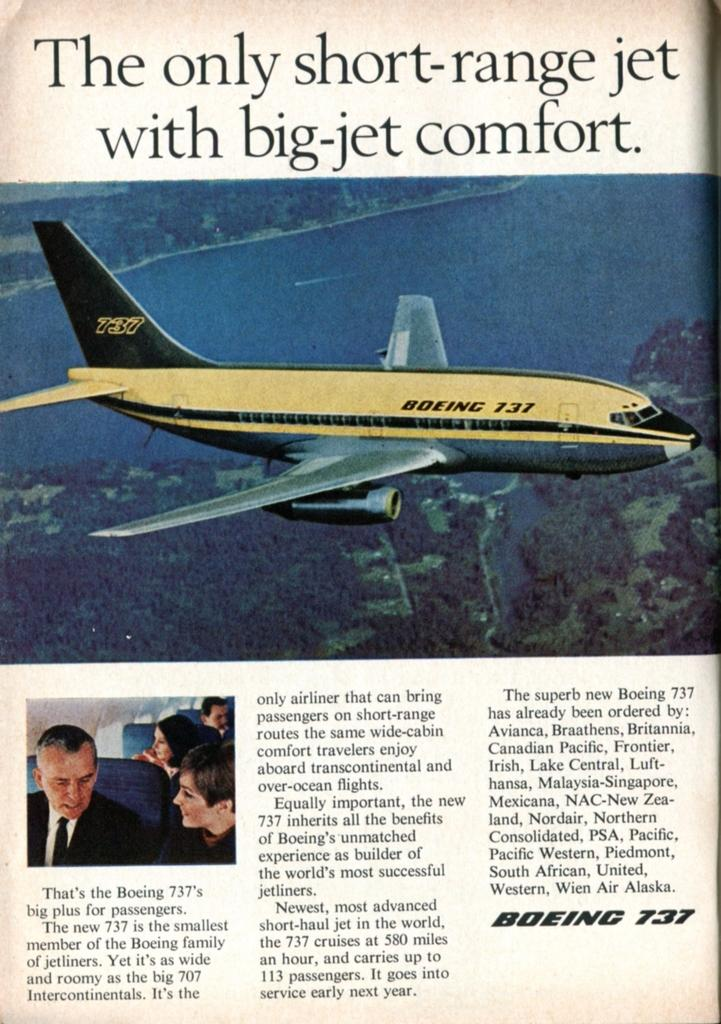What is featured on the poster in the image? There is a poster in the image, which contains an image of an airplane. Are there any other images present on the poster besides the airplane? Yes, the poster contains images of people. What is the tendency of the rock to divide in the image? There is no rock present in the image, and therefore no such division can be observed. 